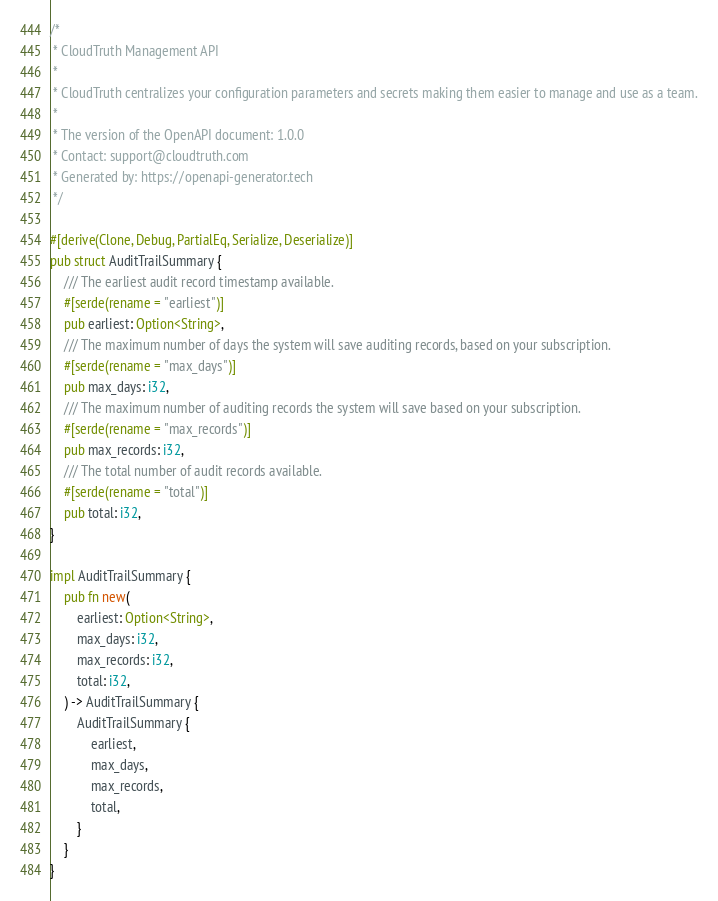Convert code to text. <code><loc_0><loc_0><loc_500><loc_500><_Rust_>/*
 * CloudTruth Management API
 *
 * CloudTruth centralizes your configuration parameters and secrets making them easier to manage and use as a team.
 *
 * The version of the OpenAPI document: 1.0.0
 * Contact: support@cloudtruth.com
 * Generated by: https://openapi-generator.tech
 */

#[derive(Clone, Debug, PartialEq, Serialize, Deserialize)]
pub struct AuditTrailSummary {
    /// The earliest audit record timestamp available.
    #[serde(rename = "earliest")]
    pub earliest: Option<String>,
    /// The maximum number of days the system will save auditing records, based on your subscription.
    #[serde(rename = "max_days")]
    pub max_days: i32,
    /// The maximum number of auditing records the system will save based on your subscription.
    #[serde(rename = "max_records")]
    pub max_records: i32,
    /// The total number of audit records available.
    #[serde(rename = "total")]
    pub total: i32,
}

impl AuditTrailSummary {
    pub fn new(
        earliest: Option<String>,
        max_days: i32,
        max_records: i32,
        total: i32,
    ) -> AuditTrailSummary {
        AuditTrailSummary {
            earliest,
            max_days,
            max_records,
            total,
        }
    }
}
</code> 